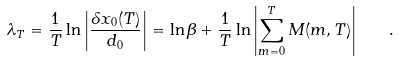Convert formula to latex. <formula><loc_0><loc_0><loc_500><loc_500>\lambda _ { T } = \frac { 1 } { T } \ln \left | \frac { \delta x _ { 0 } ( T ) } { d _ { 0 } } \right | = \ln \beta + \frac { 1 } { T } \ln \left | \sum _ { m = 0 } ^ { T } M ( m , T ) \right | \quad .</formula> 